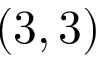Convert formula to latex. <formula><loc_0><loc_0><loc_500><loc_500>( 3 , 3 )</formula> 